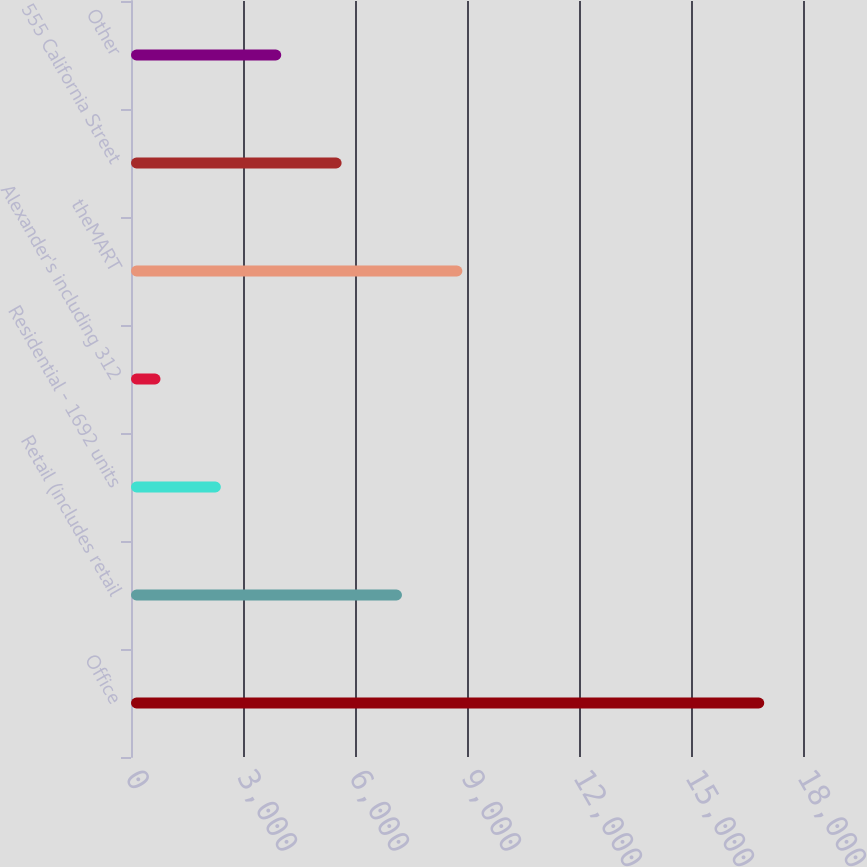Convert chart. <chart><loc_0><loc_0><loc_500><loc_500><bar_chart><fcel>Office<fcel>Retail (includes retail<fcel>Residential - 1692 units<fcel>Alexander's including 312<fcel>theMART<fcel>555 California Street<fcel>Other<nl><fcel>16962<fcel>7258.8<fcel>2407.2<fcel>790<fcel>8876<fcel>5641.6<fcel>4024.4<nl></chart> 